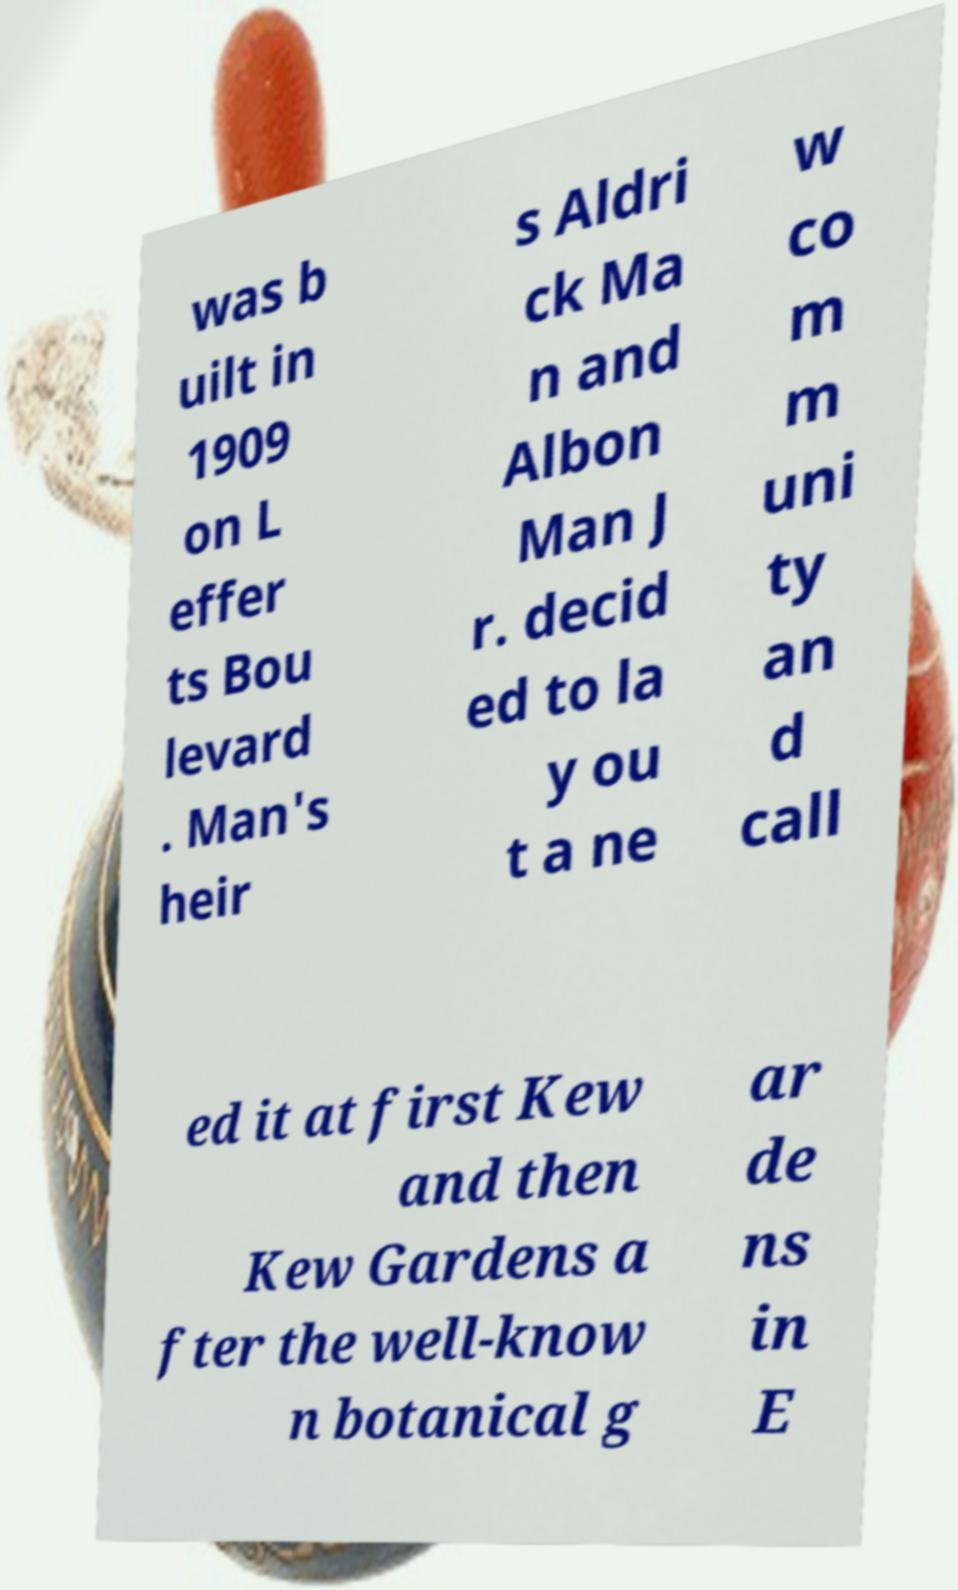Please identify and transcribe the text found in this image. was b uilt in 1909 on L effer ts Bou levard . Man's heir s Aldri ck Ma n and Albon Man J r. decid ed to la y ou t a ne w co m m uni ty an d call ed it at first Kew and then Kew Gardens a fter the well-know n botanical g ar de ns in E 